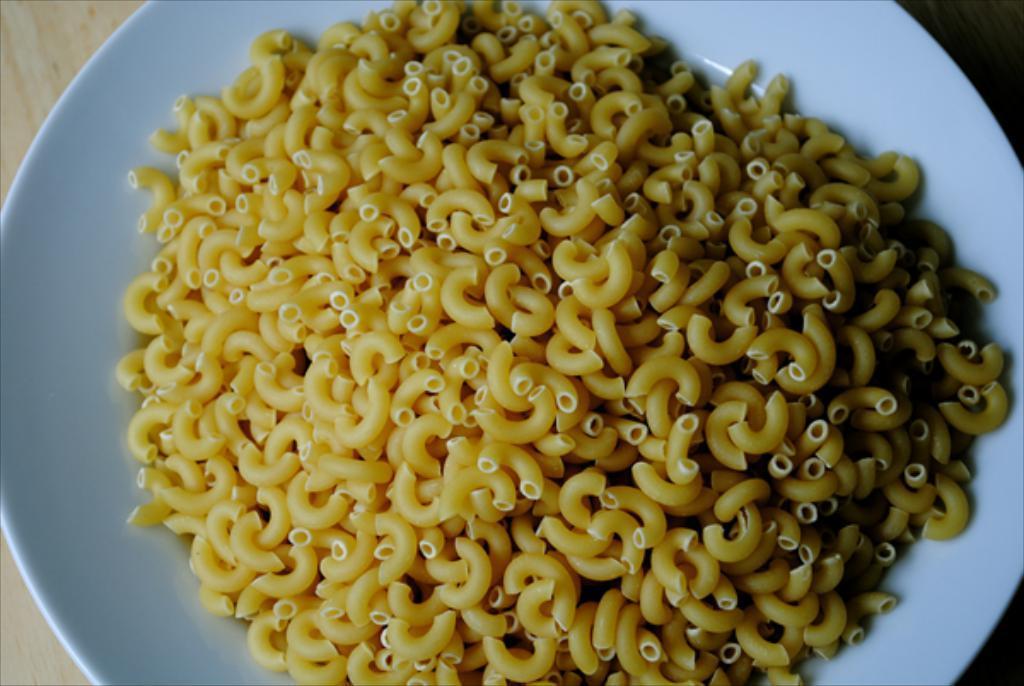What is in the center of the image? There is a plate in the center of the image. What is on the plate? The plate contains pasta. What type of surface is visible in the background of the image? There is a wooden table in the background of the image. Can you hear the plate laughing in the image? There is no sound or indication of laughter in the image; it is a still image of a plate with pasta. 